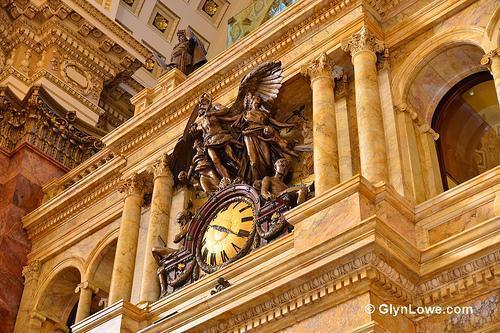How many statues are there on the very top of the building?
Give a very brief answer. 1. 